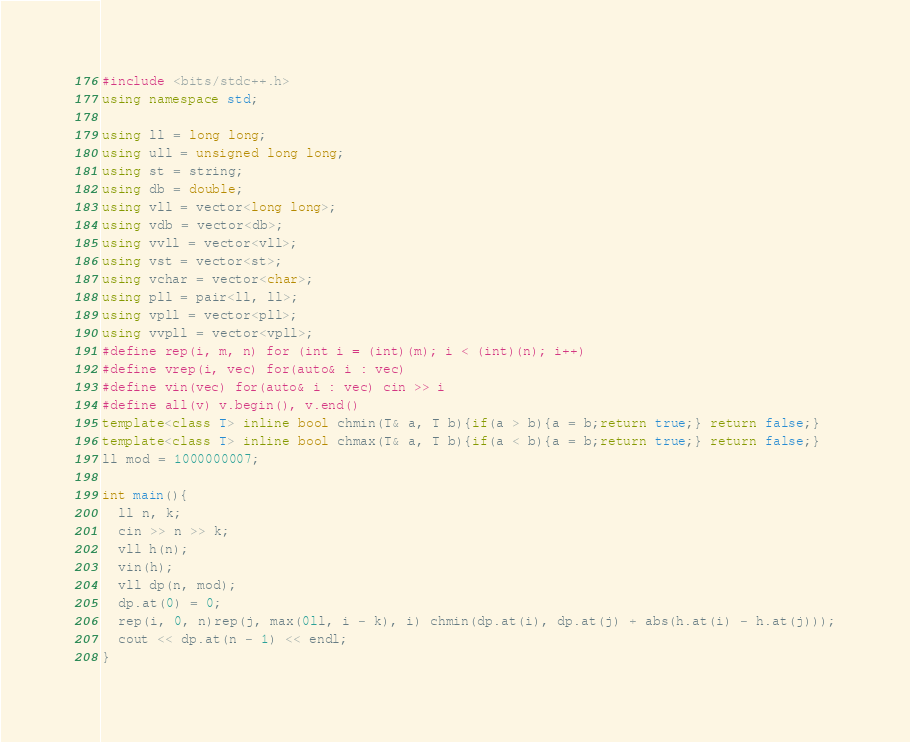Convert code to text. <code><loc_0><loc_0><loc_500><loc_500><_C++_>#include <bits/stdc++.h>
using namespace std;

using ll = long long;
using ull = unsigned long long;
using st = string;
using db = double;
using vll = vector<long long>;
using vdb = vector<db>;
using vvll = vector<vll>;
using vst = vector<st>;
using vchar = vector<char>;
using pll = pair<ll, ll>;
using vpll = vector<pll>;
using vvpll = vector<vpll>;
#define rep(i, m, n) for (int i = (int)(m); i < (int)(n); i++)
#define vrep(i, vec) for(auto& i : vec)
#define vin(vec) for(auto& i : vec) cin >> i
#define all(v) v.begin(), v.end()
template<class T> inline bool chmin(T& a, T b){if(a > b){a = b;return true;} return false;}
template<class T> inline bool chmax(T& a, T b){if(a < b){a = b;return true;} return false;}
ll mod = 1000000007;

int main(){
  ll n, k;
  cin >> n >> k;
  vll h(n);
  vin(h);
  vll dp(n, mod);
  dp.at(0) = 0;
  rep(i, 0, n)rep(j, max(0ll, i - k), i) chmin(dp.at(i), dp.at(j) + abs(h.at(i) - h.at(j)));
  cout << dp.at(n - 1) << endl;
}</code> 